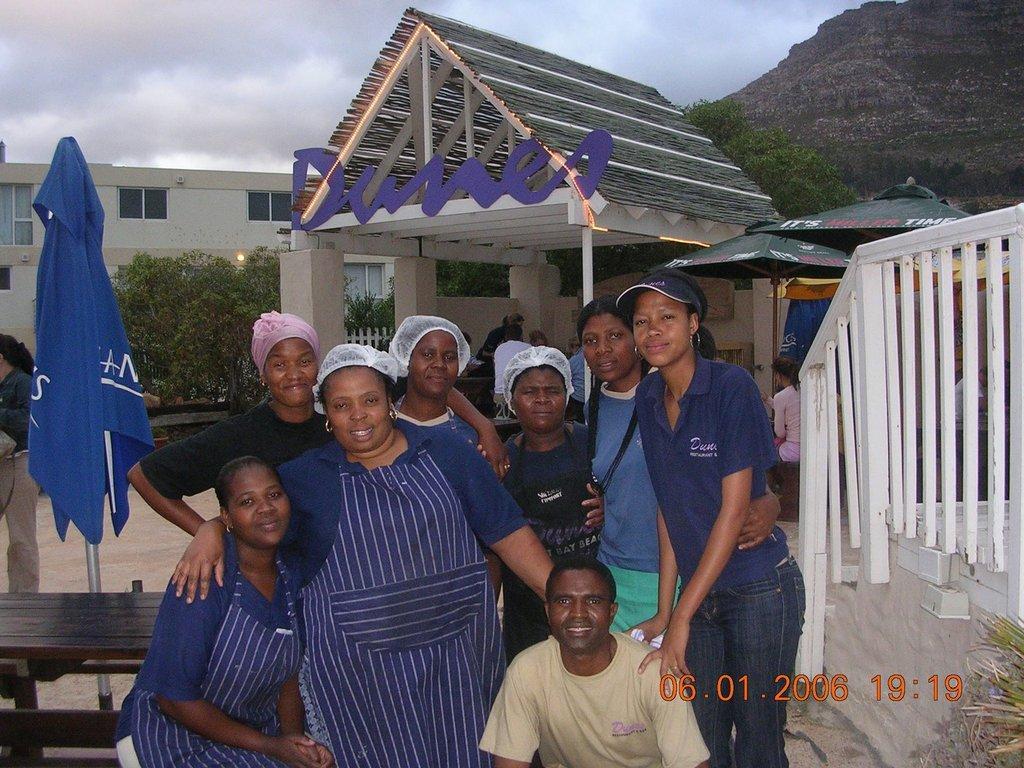Describe this image in one or two sentences. In this image I can see number of persons wearing blue t shirts are standing and a person is sitting. To the left side of the image I can see a table, a bench and a tent which is blue in color. In the background I can see few trees, a building, few other persons, the railing, few other things which are green in color, a mountain and the sky. 